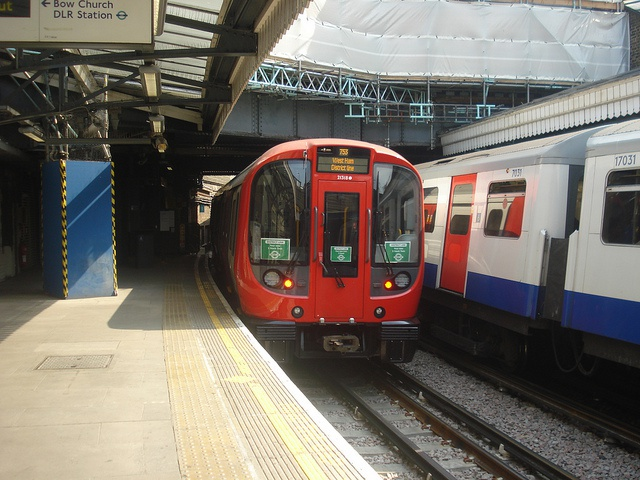Describe the objects in this image and their specific colors. I can see train in black, darkgray, navy, and lightgray tones and train in black, brown, gray, and maroon tones in this image. 